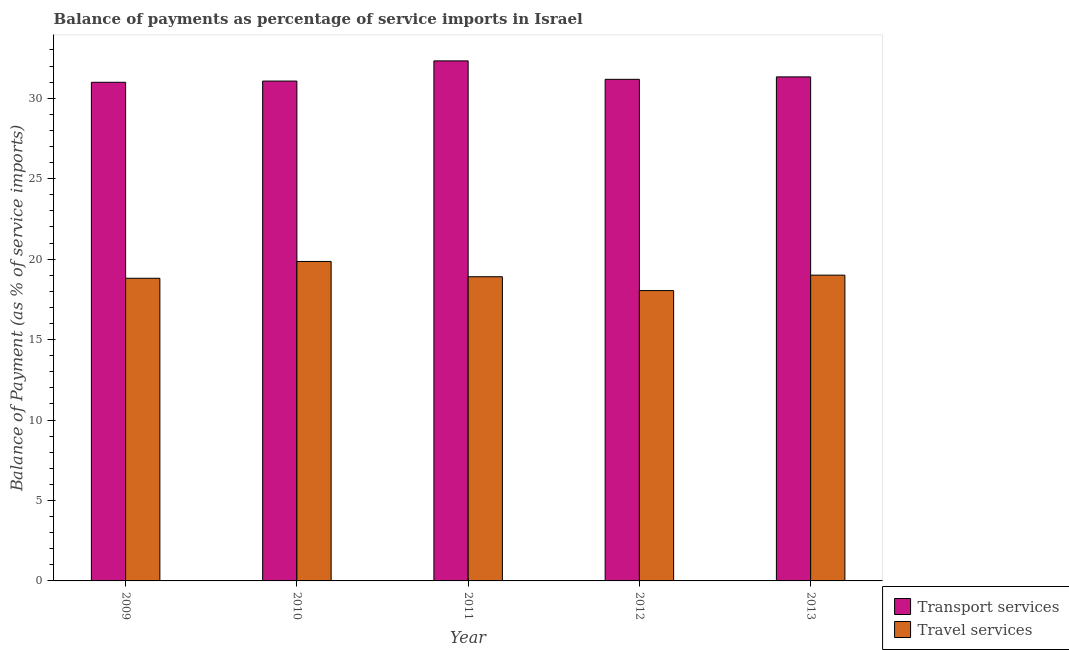How many groups of bars are there?
Provide a succinct answer. 5. Are the number of bars per tick equal to the number of legend labels?
Your answer should be very brief. Yes. Are the number of bars on each tick of the X-axis equal?
Your response must be concise. Yes. How many bars are there on the 1st tick from the right?
Provide a succinct answer. 2. What is the balance of payments of transport services in 2013?
Your response must be concise. 31.33. Across all years, what is the maximum balance of payments of transport services?
Provide a succinct answer. 32.32. Across all years, what is the minimum balance of payments of transport services?
Ensure brevity in your answer.  30.99. In which year was the balance of payments of transport services maximum?
Provide a succinct answer. 2011. What is the total balance of payments of travel services in the graph?
Provide a short and direct response. 94.62. What is the difference between the balance of payments of transport services in 2009 and that in 2010?
Ensure brevity in your answer.  -0.08. What is the difference between the balance of payments of travel services in 2010 and the balance of payments of transport services in 2009?
Provide a succinct answer. 1.04. What is the average balance of payments of travel services per year?
Offer a very short reply. 18.92. In the year 2012, what is the difference between the balance of payments of transport services and balance of payments of travel services?
Provide a short and direct response. 0. In how many years, is the balance of payments of transport services greater than 27 %?
Your answer should be compact. 5. What is the ratio of the balance of payments of travel services in 2009 to that in 2012?
Offer a very short reply. 1.04. What is the difference between the highest and the second highest balance of payments of travel services?
Offer a very short reply. 0.85. What is the difference between the highest and the lowest balance of payments of transport services?
Provide a succinct answer. 1.33. Is the sum of the balance of payments of transport services in 2010 and 2011 greater than the maximum balance of payments of travel services across all years?
Your response must be concise. Yes. What does the 1st bar from the left in 2013 represents?
Keep it short and to the point. Transport services. What does the 2nd bar from the right in 2009 represents?
Offer a very short reply. Transport services. Are all the bars in the graph horizontal?
Provide a succinct answer. No. How many years are there in the graph?
Keep it short and to the point. 5. How many legend labels are there?
Offer a very short reply. 2. What is the title of the graph?
Your answer should be compact. Balance of payments as percentage of service imports in Israel. Does "Import" appear as one of the legend labels in the graph?
Give a very brief answer. No. What is the label or title of the Y-axis?
Provide a short and direct response. Balance of Payment (as % of service imports). What is the Balance of Payment (as % of service imports) of Transport services in 2009?
Offer a very short reply. 30.99. What is the Balance of Payment (as % of service imports) in Travel services in 2009?
Ensure brevity in your answer.  18.81. What is the Balance of Payment (as % of service imports) in Transport services in 2010?
Keep it short and to the point. 31.07. What is the Balance of Payment (as % of service imports) in Travel services in 2010?
Offer a terse response. 19.86. What is the Balance of Payment (as % of service imports) of Transport services in 2011?
Provide a succinct answer. 32.32. What is the Balance of Payment (as % of service imports) of Travel services in 2011?
Keep it short and to the point. 18.9. What is the Balance of Payment (as % of service imports) of Transport services in 2012?
Provide a succinct answer. 31.18. What is the Balance of Payment (as % of service imports) in Travel services in 2012?
Offer a very short reply. 18.04. What is the Balance of Payment (as % of service imports) in Transport services in 2013?
Keep it short and to the point. 31.33. What is the Balance of Payment (as % of service imports) in Travel services in 2013?
Keep it short and to the point. 19. Across all years, what is the maximum Balance of Payment (as % of service imports) of Transport services?
Your answer should be very brief. 32.32. Across all years, what is the maximum Balance of Payment (as % of service imports) of Travel services?
Give a very brief answer. 19.86. Across all years, what is the minimum Balance of Payment (as % of service imports) in Transport services?
Ensure brevity in your answer.  30.99. Across all years, what is the minimum Balance of Payment (as % of service imports) of Travel services?
Make the answer very short. 18.04. What is the total Balance of Payment (as % of service imports) of Transport services in the graph?
Ensure brevity in your answer.  156.88. What is the total Balance of Payment (as % of service imports) of Travel services in the graph?
Provide a short and direct response. 94.62. What is the difference between the Balance of Payment (as % of service imports) of Transport services in 2009 and that in 2010?
Your answer should be compact. -0.08. What is the difference between the Balance of Payment (as % of service imports) in Travel services in 2009 and that in 2010?
Offer a very short reply. -1.04. What is the difference between the Balance of Payment (as % of service imports) of Transport services in 2009 and that in 2011?
Offer a very short reply. -1.33. What is the difference between the Balance of Payment (as % of service imports) in Travel services in 2009 and that in 2011?
Offer a very short reply. -0.09. What is the difference between the Balance of Payment (as % of service imports) of Transport services in 2009 and that in 2012?
Provide a short and direct response. -0.18. What is the difference between the Balance of Payment (as % of service imports) in Travel services in 2009 and that in 2012?
Give a very brief answer. 0.77. What is the difference between the Balance of Payment (as % of service imports) of Transport services in 2009 and that in 2013?
Your answer should be very brief. -0.34. What is the difference between the Balance of Payment (as % of service imports) in Travel services in 2009 and that in 2013?
Provide a short and direct response. -0.19. What is the difference between the Balance of Payment (as % of service imports) of Transport services in 2010 and that in 2011?
Ensure brevity in your answer.  -1.25. What is the difference between the Balance of Payment (as % of service imports) of Travel services in 2010 and that in 2011?
Provide a succinct answer. 0.95. What is the difference between the Balance of Payment (as % of service imports) in Transport services in 2010 and that in 2012?
Make the answer very short. -0.11. What is the difference between the Balance of Payment (as % of service imports) in Travel services in 2010 and that in 2012?
Provide a succinct answer. 1.81. What is the difference between the Balance of Payment (as % of service imports) of Transport services in 2010 and that in 2013?
Your answer should be very brief. -0.26. What is the difference between the Balance of Payment (as % of service imports) in Travel services in 2010 and that in 2013?
Offer a very short reply. 0.85. What is the difference between the Balance of Payment (as % of service imports) of Transport services in 2011 and that in 2012?
Your answer should be compact. 1.15. What is the difference between the Balance of Payment (as % of service imports) of Travel services in 2011 and that in 2012?
Make the answer very short. 0.86. What is the difference between the Balance of Payment (as % of service imports) in Transport services in 2011 and that in 2013?
Make the answer very short. 1. What is the difference between the Balance of Payment (as % of service imports) in Travel services in 2011 and that in 2013?
Ensure brevity in your answer.  -0.1. What is the difference between the Balance of Payment (as % of service imports) in Transport services in 2012 and that in 2013?
Your response must be concise. -0.15. What is the difference between the Balance of Payment (as % of service imports) in Travel services in 2012 and that in 2013?
Your answer should be very brief. -0.96. What is the difference between the Balance of Payment (as % of service imports) of Transport services in 2009 and the Balance of Payment (as % of service imports) of Travel services in 2010?
Ensure brevity in your answer.  11.14. What is the difference between the Balance of Payment (as % of service imports) in Transport services in 2009 and the Balance of Payment (as % of service imports) in Travel services in 2011?
Keep it short and to the point. 12.09. What is the difference between the Balance of Payment (as % of service imports) of Transport services in 2009 and the Balance of Payment (as % of service imports) of Travel services in 2012?
Make the answer very short. 12.95. What is the difference between the Balance of Payment (as % of service imports) of Transport services in 2009 and the Balance of Payment (as % of service imports) of Travel services in 2013?
Your answer should be very brief. 11.99. What is the difference between the Balance of Payment (as % of service imports) of Transport services in 2010 and the Balance of Payment (as % of service imports) of Travel services in 2011?
Offer a very short reply. 12.16. What is the difference between the Balance of Payment (as % of service imports) of Transport services in 2010 and the Balance of Payment (as % of service imports) of Travel services in 2012?
Make the answer very short. 13.02. What is the difference between the Balance of Payment (as % of service imports) of Transport services in 2010 and the Balance of Payment (as % of service imports) of Travel services in 2013?
Your answer should be very brief. 12.06. What is the difference between the Balance of Payment (as % of service imports) in Transport services in 2011 and the Balance of Payment (as % of service imports) in Travel services in 2012?
Give a very brief answer. 14.28. What is the difference between the Balance of Payment (as % of service imports) of Transport services in 2011 and the Balance of Payment (as % of service imports) of Travel services in 2013?
Make the answer very short. 13.32. What is the difference between the Balance of Payment (as % of service imports) of Transport services in 2012 and the Balance of Payment (as % of service imports) of Travel services in 2013?
Your response must be concise. 12.17. What is the average Balance of Payment (as % of service imports) of Transport services per year?
Provide a short and direct response. 31.38. What is the average Balance of Payment (as % of service imports) of Travel services per year?
Provide a short and direct response. 18.92. In the year 2009, what is the difference between the Balance of Payment (as % of service imports) of Transport services and Balance of Payment (as % of service imports) of Travel services?
Give a very brief answer. 12.18. In the year 2010, what is the difference between the Balance of Payment (as % of service imports) of Transport services and Balance of Payment (as % of service imports) of Travel services?
Give a very brief answer. 11.21. In the year 2011, what is the difference between the Balance of Payment (as % of service imports) in Transport services and Balance of Payment (as % of service imports) in Travel services?
Offer a very short reply. 13.42. In the year 2012, what is the difference between the Balance of Payment (as % of service imports) of Transport services and Balance of Payment (as % of service imports) of Travel services?
Provide a short and direct response. 13.13. In the year 2013, what is the difference between the Balance of Payment (as % of service imports) in Transport services and Balance of Payment (as % of service imports) in Travel services?
Your response must be concise. 12.32. What is the ratio of the Balance of Payment (as % of service imports) in Travel services in 2009 to that in 2010?
Provide a succinct answer. 0.95. What is the ratio of the Balance of Payment (as % of service imports) of Transport services in 2009 to that in 2011?
Make the answer very short. 0.96. What is the ratio of the Balance of Payment (as % of service imports) of Transport services in 2009 to that in 2012?
Offer a terse response. 0.99. What is the ratio of the Balance of Payment (as % of service imports) of Travel services in 2009 to that in 2012?
Ensure brevity in your answer.  1.04. What is the ratio of the Balance of Payment (as % of service imports) in Transport services in 2009 to that in 2013?
Keep it short and to the point. 0.99. What is the ratio of the Balance of Payment (as % of service imports) of Transport services in 2010 to that in 2011?
Offer a terse response. 0.96. What is the ratio of the Balance of Payment (as % of service imports) in Travel services in 2010 to that in 2011?
Your response must be concise. 1.05. What is the ratio of the Balance of Payment (as % of service imports) of Transport services in 2010 to that in 2012?
Your answer should be very brief. 1. What is the ratio of the Balance of Payment (as % of service imports) in Travel services in 2010 to that in 2012?
Make the answer very short. 1.1. What is the ratio of the Balance of Payment (as % of service imports) in Travel services in 2010 to that in 2013?
Your response must be concise. 1.04. What is the ratio of the Balance of Payment (as % of service imports) in Transport services in 2011 to that in 2012?
Make the answer very short. 1.04. What is the ratio of the Balance of Payment (as % of service imports) of Travel services in 2011 to that in 2012?
Keep it short and to the point. 1.05. What is the ratio of the Balance of Payment (as % of service imports) of Transport services in 2011 to that in 2013?
Offer a terse response. 1.03. What is the ratio of the Balance of Payment (as % of service imports) of Travel services in 2011 to that in 2013?
Your answer should be compact. 0.99. What is the ratio of the Balance of Payment (as % of service imports) in Transport services in 2012 to that in 2013?
Offer a terse response. 1. What is the ratio of the Balance of Payment (as % of service imports) of Travel services in 2012 to that in 2013?
Give a very brief answer. 0.95. What is the difference between the highest and the second highest Balance of Payment (as % of service imports) in Transport services?
Make the answer very short. 1. What is the difference between the highest and the second highest Balance of Payment (as % of service imports) of Travel services?
Offer a very short reply. 0.85. What is the difference between the highest and the lowest Balance of Payment (as % of service imports) in Transport services?
Provide a short and direct response. 1.33. What is the difference between the highest and the lowest Balance of Payment (as % of service imports) in Travel services?
Ensure brevity in your answer.  1.81. 